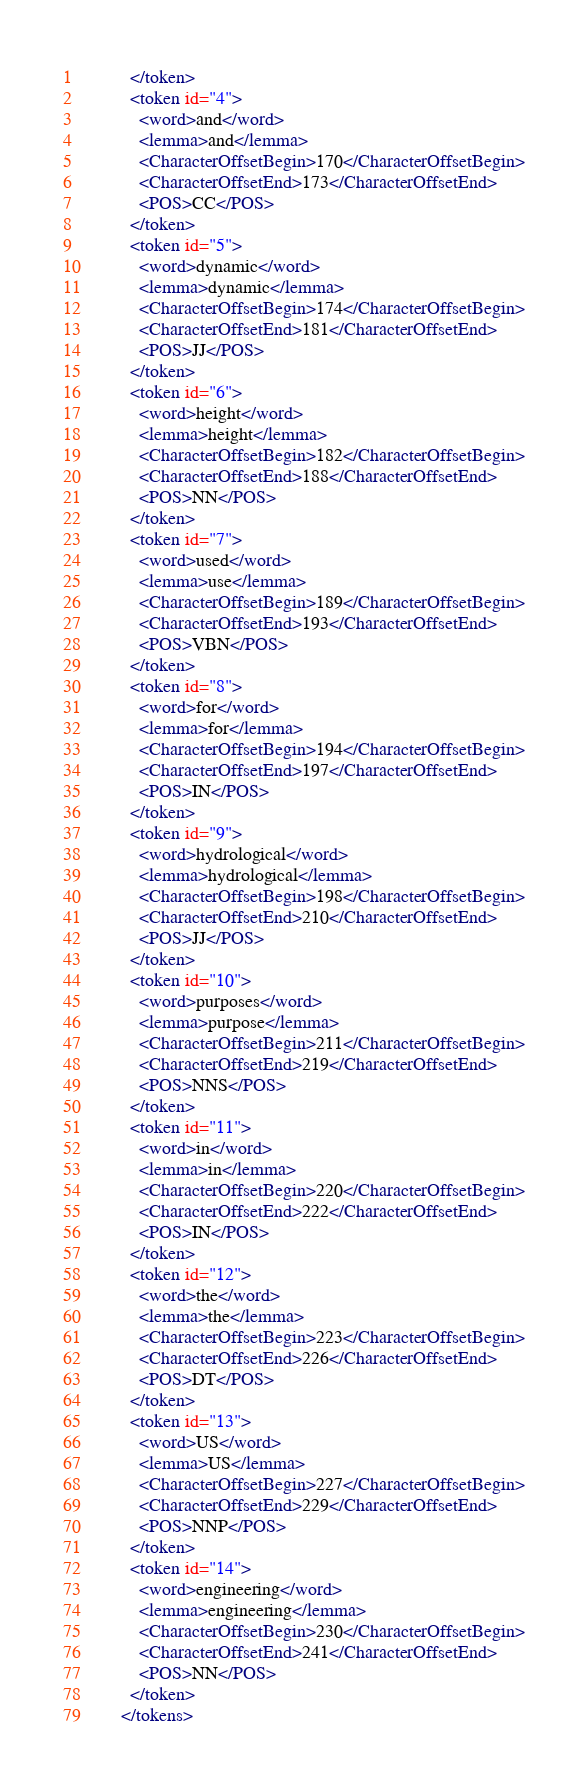Convert code to text. <code><loc_0><loc_0><loc_500><loc_500><_XML_>          </token>
          <token id="4">
            <word>and</word>
            <lemma>and</lemma>
            <CharacterOffsetBegin>170</CharacterOffsetBegin>
            <CharacterOffsetEnd>173</CharacterOffsetEnd>
            <POS>CC</POS>
          </token>
          <token id="5">
            <word>dynamic</word>
            <lemma>dynamic</lemma>
            <CharacterOffsetBegin>174</CharacterOffsetBegin>
            <CharacterOffsetEnd>181</CharacterOffsetEnd>
            <POS>JJ</POS>
          </token>
          <token id="6">
            <word>height</word>
            <lemma>height</lemma>
            <CharacterOffsetBegin>182</CharacterOffsetBegin>
            <CharacterOffsetEnd>188</CharacterOffsetEnd>
            <POS>NN</POS>
          </token>
          <token id="7">
            <word>used</word>
            <lemma>use</lemma>
            <CharacterOffsetBegin>189</CharacterOffsetBegin>
            <CharacterOffsetEnd>193</CharacterOffsetEnd>
            <POS>VBN</POS>
          </token>
          <token id="8">
            <word>for</word>
            <lemma>for</lemma>
            <CharacterOffsetBegin>194</CharacterOffsetBegin>
            <CharacterOffsetEnd>197</CharacterOffsetEnd>
            <POS>IN</POS>
          </token>
          <token id="9">
            <word>hydrological</word>
            <lemma>hydrological</lemma>
            <CharacterOffsetBegin>198</CharacterOffsetBegin>
            <CharacterOffsetEnd>210</CharacterOffsetEnd>
            <POS>JJ</POS>
          </token>
          <token id="10">
            <word>purposes</word>
            <lemma>purpose</lemma>
            <CharacterOffsetBegin>211</CharacterOffsetBegin>
            <CharacterOffsetEnd>219</CharacterOffsetEnd>
            <POS>NNS</POS>
          </token>
          <token id="11">
            <word>in</word>
            <lemma>in</lemma>
            <CharacterOffsetBegin>220</CharacterOffsetBegin>
            <CharacterOffsetEnd>222</CharacterOffsetEnd>
            <POS>IN</POS>
          </token>
          <token id="12">
            <word>the</word>
            <lemma>the</lemma>
            <CharacterOffsetBegin>223</CharacterOffsetBegin>
            <CharacterOffsetEnd>226</CharacterOffsetEnd>
            <POS>DT</POS>
          </token>
          <token id="13">
            <word>US</word>
            <lemma>US</lemma>
            <CharacterOffsetBegin>227</CharacterOffsetBegin>
            <CharacterOffsetEnd>229</CharacterOffsetEnd>
            <POS>NNP</POS>
          </token>
          <token id="14">
            <word>engineering</word>
            <lemma>engineering</lemma>
            <CharacterOffsetBegin>230</CharacterOffsetBegin>
            <CharacterOffsetEnd>241</CharacterOffsetEnd>
            <POS>NN</POS>
          </token>
        </tokens></code> 